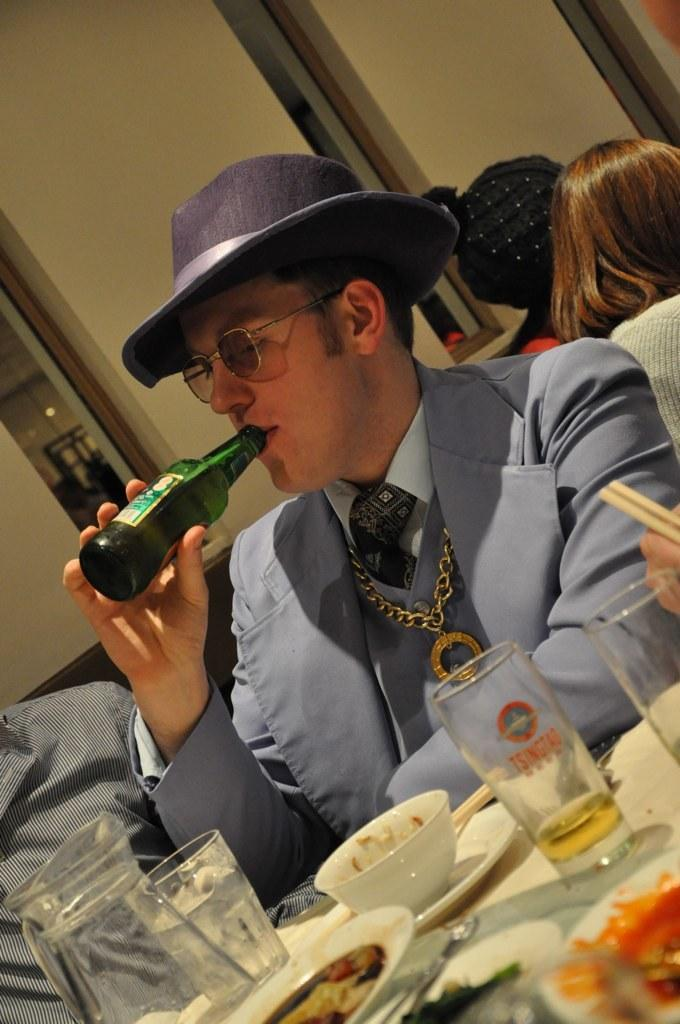Who is present in the image? There is a man in the image. What is the man doing in the image? The man is sitting. What object is the man holding in the image? The man is holding a wine bottle. What type of flower is the man planting with a rake in the image? There is no flower or rake present in the image; the man is sitting and holding a wine bottle. 